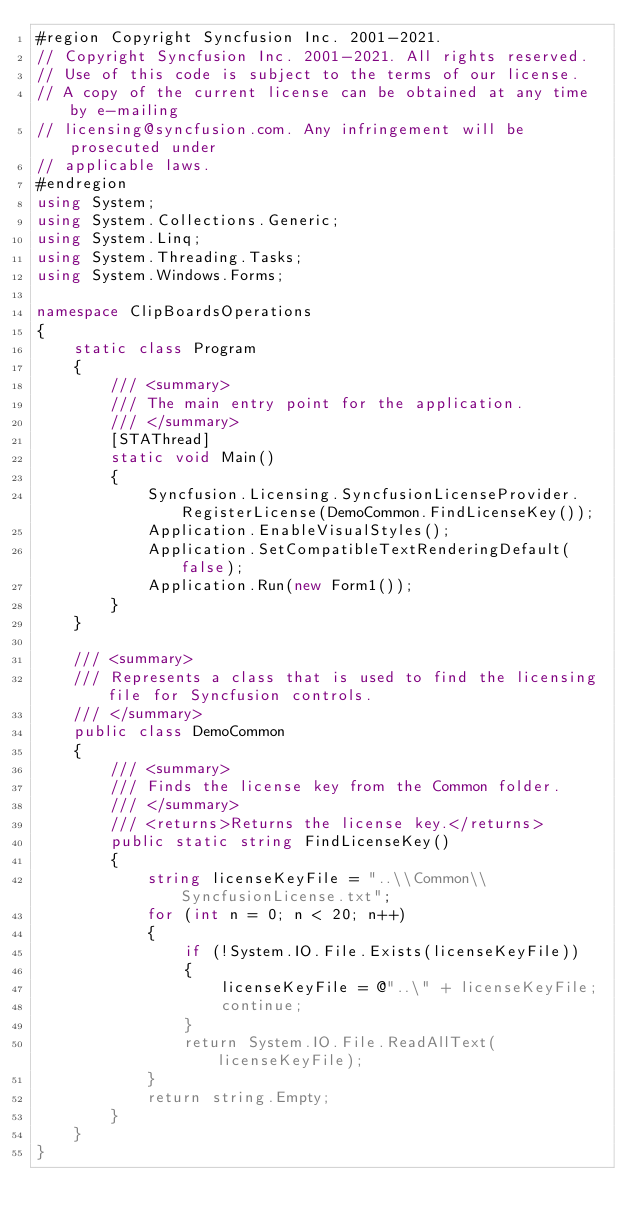Convert code to text. <code><loc_0><loc_0><loc_500><loc_500><_C#_>#region Copyright Syncfusion Inc. 2001-2021.
// Copyright Syncfusion Inc. 2001-2021. All rights reserved.
// Use of this code is subject to the terms of our license.
// A copy of the current license can be obtained at any time by e-mailing
// licensing@syncfusion.com. Any infringement will be prosecuted under
// applicable laws. 
#endregion
using System;
using System.Collections.Generic;
using System.Linq;
using System.Threading.Tasks;
using System.Windows.Forms;

namespace ClipBoardsOperations
{
    static class Program
    {
        /// <summary>
        /// The main entry point for the application.
        /// </summary>
        [STAThread]
        static void Main()
        {
			Syncfusion.Licensing.SyncfusionLicenseProvider.RegisterLicense(DemoCommon.FindLicenseKey());
            Application.EnableVisualStyles();
            Application.SetCompatibleTextRenderingDefault(false);
            Application.Run(new Form1());
        }
    }
	
	/// <summary>
    /// Represents a class that is used to find the licensing file for Syncfusion controls.
    /// </summary>
    public class DemoCommon
    {
        /// <summary>
        /// Finds the license key from the Common folder.
        /// </summary>
        /// <returns>Returns the license key.</returns>
        public static string FindLicenseKey()
        {
            string licenseKeyFile = "..\\Common\\SyncfusionLicense.txt";
            for (int n = 0; n < 20; n++)
            {
                if (!System.IO.File.Exists(licenseKeyFile))
                {
                    licenseKeyFile = @"..\" + licenseKeyFile;
                    continue;
                }
                return System.IO.File.ReadAllText(licenseKeyFile);
            }
            return string.Empty;
        }
    }
}
</code> 